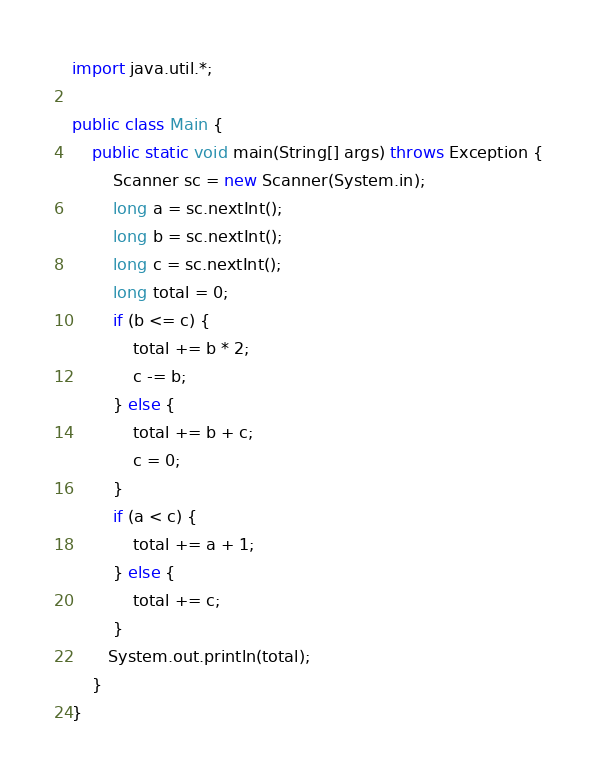<code> <loc_0><loc_0><loc_500><loc_500><_Java_>import java.util.*;

public class Main {
    public static void main(String[] args) throws Exception {
        Scanner sc = new Scanner(System.in);
        long a = sc.nextInt();
        long b = sc.nextInt();
        long c = sc.nextInt();
        long total = 0;
        if (b <= c) {
            total += b * 2;
            c -= b;
        } else {
            total += b + c;
            c = 0;
        }
        if (a < c) {
            total += a + 1;
        } else {
            total += c;
        }
       System.out.println(total);
    }
}
</code> 